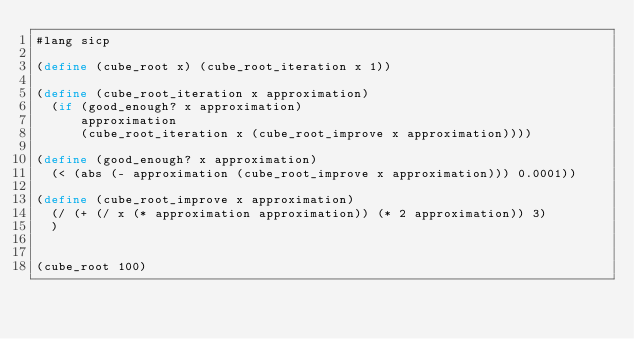Convert code to text. <code><loc_0><loc_0><loc_500><loc_500><_Scheme_>#lang sicp

(define (cube_root x) (cube_root_iteration x 1))

(define (cube_root_iteration x approximation)
  (if (good_enough? x approximation)
      approximation
      (cube_root_iteration x (cube_root_improve x approximation))))

(define (good_enough? x approximation)
  (< (abs (- approximation (cube_root_improve x approximation))) 0.0001))

(define (cube_root_improve x approximation)
  (/ (+ (/ x (* approximation approximation)) (* 2 approximation)) 3)
  )


(cube_root 100)</code> 